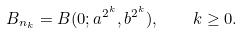<formula> <loc_0><loc_0><loc_500><loc_500>B _ { n _ { k } } = B ( 0 ; a ^ { 2 ^ { k } } , b ^ { 2 ^ { k } } ) , \quad k \geq 0 .</formula> 